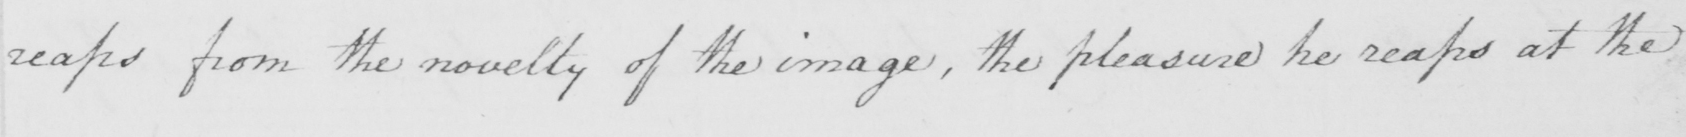Can you read and transcribe this handwriting? reaps from the novelty of the image , the pleasure he reaps at the 